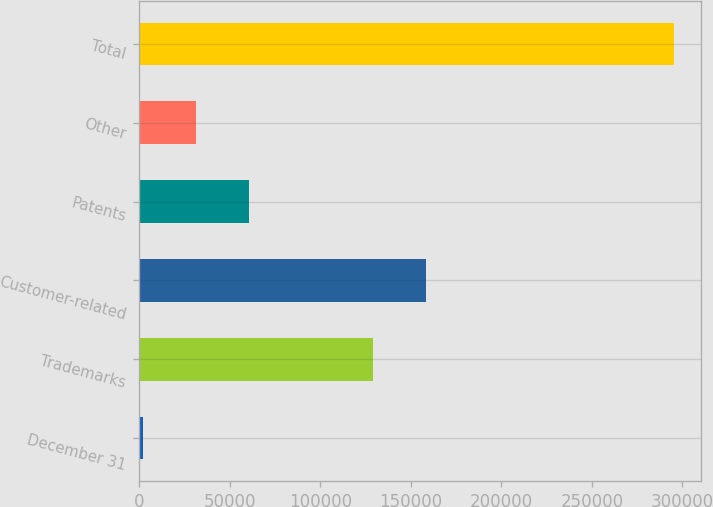Convert chart. <chart><loc_0><loc_0><loc_500><loc_500><bar_chart><fcel>December 31<fcel>Trademarks<fcel>Customer-related<fcel>Patents<fcel>Other<fcel>Total<nl><fcel>2014<fcel>129223<fcel>158559<fcel>60686.2<fcel>31350.1<fcel>295375<nl></chart> 